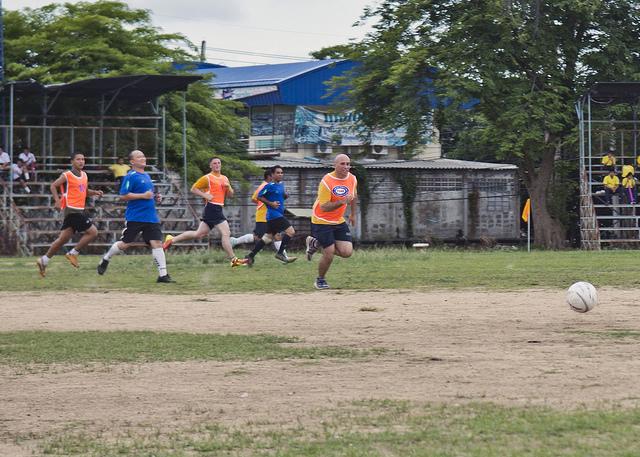Are the people all on the same team?
Quick response, please. No. What animals are in the image?
Concise answer only. None. Which team is winning?
Keep it brief. Orange. What sport are the men playing?
Write a very short answer. Soccer. What are the orange things on the field?
Quick response, please. Vests. How many signs are in the background?
Write a very short answer. 1. How many dogs are in the photo?
Keep it brief. 0. 